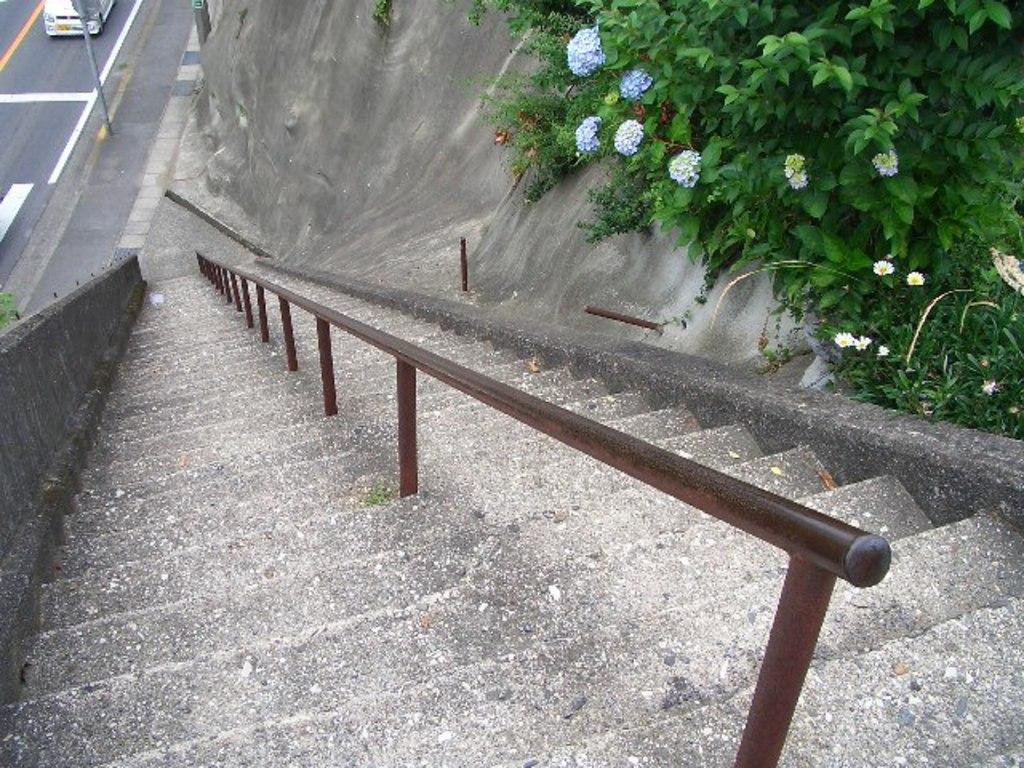Please provide a concise description of this image. The picture is captured by standing above the stairs and beside the stairs there are some flower plants and in the left side of the stairs there is a road and there is a vehicle moving on the road. 